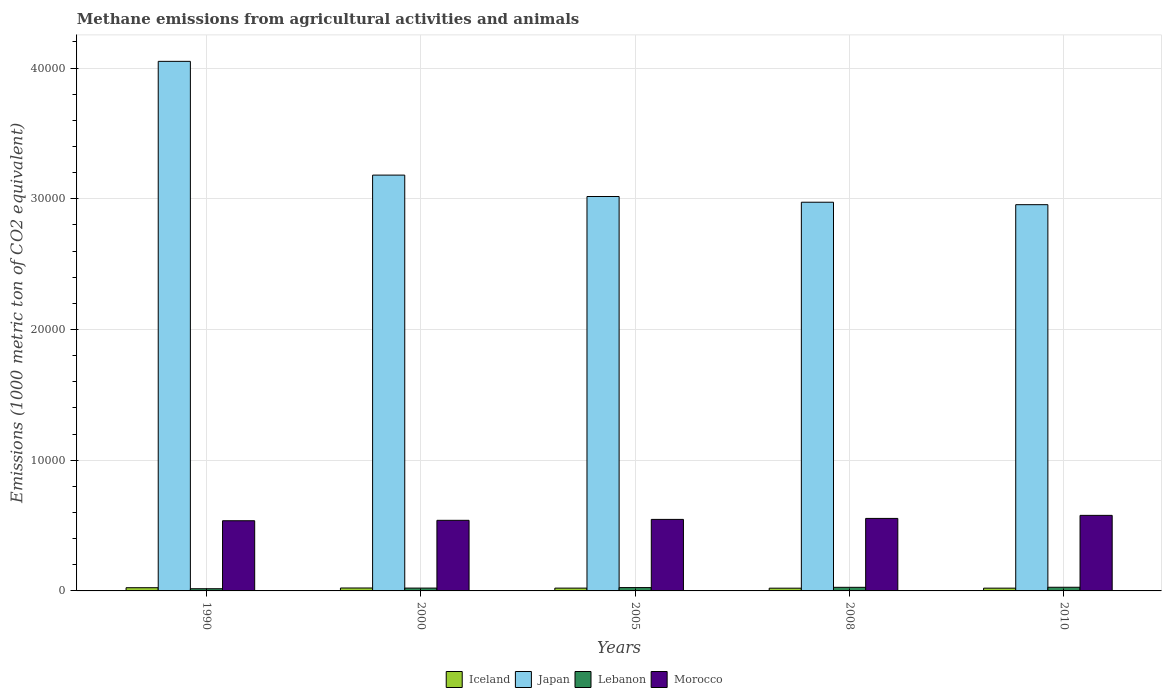How many different coloured bars are there?
Give a very brief answer. 4. How many bars are there on the 4th tick from the left?
Your answer should be compact. 4. What is the label of the 2nd group of bars from the left?
Your answer should be very brief. 2000. What is the amount of methane emitted in Japan in 2005?
Give a very brief answer. 3.02e+04. Across all years, what is the maximum amount of methane emitted in Iceland?
Your answer should be compact. 245.3. Across all years, what is the minimum amount of methane emitted in Iceland?
Make the answer very short. 209.2. In which year was the amount of methane emitted in Morocco minimum?
Ensure brevity in your answer.  1990. What is the total amount of methane emitted in Lebanon in the graph?
Your response must be concise. 1194.5. What is the difference between the amount of methane emitted in Japan in 2008 and the amount of methane emitted in Morocco in 2005?
Keep it short and to the point. 2.43e+04. What is the average amount of methane emitted in Morocco per year?
Provide a short and direct response. 5513.2. In the year 2000, what is the difference between the amount of methane emitted in Morocco and amount of methane emitted in Iceland?
Make the answer very short. 5176.6. What is the ratio of the amount of methane emitted in Iceland in 1990 to that in 2000?
Give a very brief answer. 1.1. Is the difference between the amount of methane emitted in Morocco in 2005 and 2008 greater than the difference between the amount of methane emitted in Iceland in 2005 and 2008?
Your response must be concise. No. What is the difference between the highest and the second highest amount of methane emitted in Japan?
Keep it short and to the point. 8700.7. What is the difference between the highest and the lowest amount of methane emitted in Iceland?
Provide a short and direct response. 36.1. What does the 1st bar from the left in 2005 represents?
Your response must be concise. Iceland. What does the 3rd bar from the right in 2008 represents?
Provide a succinct answer. Japan. Is it the case that in every year, the sum of the amount of methane emitted in Lebanon and amount of methane emitted in Iceland is greater than the amount of methane emitted in Morocco?
Your answer should be compact. No. Are all the bars in the graph horizontal?
Provide a succinct answer. No. How many years are there in the graph?
Provide a short and direct response. 5. Does the graph contain any zero values?
Make the answer very short. No. Does the graph contain grids?
Offer a very short reply. Yes. Where does the legend appear in the graph?
Make the answer very short. Bottom center. How are the legend labels stacked?
Ensure brevity in your answer.  Horizontal. What is the title of the graph?
Your response must be concise. Methane emissions from agricultural activities and animals. Does "Central Europe" appear as one of the legend labels in the graph?
Your response must be concise. No. What is the label or title of the Y-axis?
Give a very brief answer. Emissions (1000 metric ton of CO2 equivalent). What is the Emissions (1000 metric ton of CO2 equivalent) of Iceland in 1990?
Offer a terse response. 245.3. What is the Emissions (1000 metric ton of CO2 equivalent) of Japan in 1990?
Your answer should be very brief. 4.05e+04. What is the Emissions (1000 metric ton of CO2 equivalent) of Lebanon in 1990?
Offer a very short reply. 167.6. What is the Emissions (1000 metric ton of CO2 equivalent) of Morocco in 1990?
Offer a very short reply. 5368.8. What is the Emissions (1000 metric ton of CO2 equivalent) in Iceland in 2000?
Make the answer very short. 223.7. What is the Emissions (1000 metric ton of CO2 equivalent) in Japan in 2000?
Your answer should be compact. 3.18e+04. What is the Emissions (1000 metric ton of CO2 equivalent) of Lebanon in 2000?
Ensure brevity in your answer.  216.7. What is the Emissions (1000 metric ton of CO2 equivalent) of Morocco in 2000?
Offer a very short reply. 5400.3. What is the Emissions (1000 metric ton of CO2 equivalent) of Iceland in 2005?
Your answer should be compact. 214.9. What is the Emissions (1000 metric ton of CO2 equivalent) of Japan in 2005?
Offer a terse response. 3.02e+04. What is the Emissions (1000 metric ton of CO2 equivalent) of Lebanon in 2005?
Your answer should be very brief. 255.2. What is the Emissions (1000 metric ton of CO2 equivalent) of Morocco in 2005?
Give a very brief answer. 5471.4. What is the Emissions (1000 metric ton of CO2 equivalent) of Iceland in 2008?
Provide a short and direct response. 209.2. What is the Emissions (1000 metric ton of CO2 equivalent) in Japan in 2008?
Your response must be concise. 2.97e+04. What is the Emissions (1000 metric ton of CO2 equivalent) in Lebanon in 2008?
Ensure brevity in your answer.  275. What is the Emissions (1000 metric ton of CO2 equivalent) in Morocco in 2008?
Ensure brevity in your answer.  5546.4. What is the Emissions (1000 metric ton of CO2 equivalent) of Iceland in 2010?
Provide a succinct answer. 212.4. What is the Emissions (1000 metric ton of CO2 equivalent) of Japan in 2010?
Offer a very short reply. 2.95e+04. What is the Emissions (1000 metric ton of CO2 equivalent) in Lebanon in 2010?
Your response must be concise. 280. What is the Emissions (1000 metric ton of CO2 equivalent) in Morocco in 2010?
Your answer should be very brief. 5779.1. Across all years, what is the maximum Emissions (1000 metric ton of CO2 equivalent) in Iceland?
Your answer should be very brief. 245.3. Across all years, what is the maximum Emissions (1000 metric ton of CO2 equivalent) of Japan?
Provide a short and direct response. 4.05e+04. Across all years, what is the maximum Emissions (1000 metric ton of CO2 equivalent) in Lebanon?
Your response must be concise. 280. Across all years, what is the maximum Emissions (1000 metric ton of CO2 equivalent) in Morocco?
Give a very brief answer. 5779.1. Across all years, what is the minimum Emissions (1000 metric ton of CO2 equivalent) in Iceland?
Keep it short and to the point. 209.2. Across all years, what is the minimum Emissions (1000 metric ton of CO2 equivalent) in Japan?
Offer a terse response. 2.95e+04. Across all years, what is the minimum Emissions (1000 metric ton of CO2 equivalent) of Lebanon?
Provide a succinct answer. 167.6. Across all years, what is the minimum Emissions (1000 metric ton of CO2 equivalent) in Morocco?
Ensure brevity in your answer.  5368.8. What is the total Emissions (1000 metric ton of CO2 equivalent) in Iceland in the graph?
Offer a terse response. 1105.5. What is the total Emissions (1000 metric ton of CO2 equivalent) in Japan in the graph?
Offer a terse response. 1.62e+05. What is the total Emissions (1000 metric ton of CO2 equivalent) in Lebanon in the graph?
Give a very brief answer. 1194.5. What is the total Emissions (1000 metric ton of CO2 equivalent) of Morocco in the graph?
Your answer should be very brief. 2.76e+04. What is the difference between the Emissions (1000 metric ton of CO2 equivalent) in Iceland in 1990 and that in 2000?
Offer a terse response. 21.6. What is the difference between the Emissions (1000 metric ton of CO2 equivalent) in Japan in 1990 and that in 2000?
Your response must be concise. 8700.7. What is the difference between the Emissions (1000 metric ton of CO2 equivalent) of Lebanon in 1990 and that in 2000?
Offer a terse response. -49.1. What is the difference between the Emissions (1000 metric ton of CO2 equivalent) of Morocco in 1990 and that in 2000?
Your response must be concise. -31.5. What is the difference between the Emissions (1000 metric ton of CO2 equivalent) in Iceland in 1990 and that in 2005?
Offer a terse response. 30.4. What is the difference between the Emissions (1000 metric ton of CO2 equivalent) in Japan in 1990 and that in 2005?
Your answer should be compact. 1.03e+04. What is the difference between the Emissions (1000 metric ton of CO2 equivalent) of Lebanon in 1990 and that in 2005?
Your response must be concise. -87.6. What is the difference between the Emissions (1000 metric ton of CO2 equivalent) in Morocco in 1990 and that in 2005?
Your answer should be compact. -102.6. What is the difference between the Emissions (1000 metric ton of CO2 equivalent) in Iceland in 1990 and that in 2008?
Provide a short and direct response. 36.1. What is the difference between the Emissions (1000 metric ton of CO2 equivalent) in Japan in 1990 and that in 2008?
Offer a terse response. 1.08e+04. What is the difference between the Emissions (1000 metric ton of CO2 equivalent) of Lebanon in 1990 and that in 2008?
Ensure brevity in your answer.  -107.4. What is the difference between the Emissions (1000 metric ton of CO2 equivalent) in Morocco in 1990 and that in 2008?
Keep it short and to the point. -177.6. What is the difference between the Emissions (1000 metric ton of CO2 equivalent) in Iceland in 1990 and that in 2010?
Give a very brief answer. 32.9. What is the difference between the Emissions (1000 metric ton of CO2 equivalent) of Japan in 1990 and that in 2010?
Your answer should be very brief. 1.10e+04. What is the difference between the Emissions (1000 metric ton of CO2 equivalent) of Lebanon in 1990 and that in 2010?
Your response must be concise. -112.4. What is the difference between the Emissions (1000 metric ton of CO2 equivalent) of Morocco in 1990 and that in 2010?
Your response must be concise. -410.3. What is the difference between the Emissions (1000 metric ton of CO2 equivalent) in Iceland in 2000 and that in 2005?
Provide a succinct answer. 8.8. What is the difference between the Emissions (1000 metric ton of CO2 equivalent) of Japan in 2000 and that in 2005?
Your answer should be very brief. 1638. What is the difference between the Emissions (1000 metric ton of CO2 equivalent) in Lebanon in 2000 and that in 2005?
Provide a short and direct response. -38.5. What is the difference between the Emissions (1000 metric ton of CO2 equivalent) of Morocco in 2000 and that in 2005?
Keep it short and to the point. -71.1. What is the difference between the Emissions (1000 metric ton of CO2 equivalent) of Iceland in 2000 and that in 2008?
Make the answer very short. 14.5. What is the difference between the Emissions (1000 metric ton of CO2 equivalent) of Japan in 2000 and that in 2008?
Make the answer very short. 2075.3. What is the difference between the Emissions (1000 metric ton of CO2 equivalent) of Lebanon in 2000 and that in 2008?
Your response must be concise. -58.3. What is the difference between the Emissions (1000 metric ton of CO2 equivalent) in Morocco in 2000 and that in 2008?
Provide a succinct answer. -146.1. What is the difference between the Emissions (1000 metric ton of CO2 equivalent) in Iceland in 2000 and that in 2010?
Provide a succinct answer. 11.3. What is the difference between the Emissions (1000 metric ton of CO2 equivalent) of Japan in 2000 and that in 2010?
Provide a short and direct response. 2263.3. What is the difference between the Emissions (1000 metric ton of CO2 equivalent) of Lebanon in 2000 and that in 2010?
Provide a short and direct response. -63.3. What is the difference between the Emissions (1000 metric ton of CO2 equivalent) of Morocco in 2000 and that in 2010?
Provide a short and direct response. -378.8. What is the difference between the Emissions (1000 metric ton of CO2 equivalent) of Japan in 2005 and that in 2008?
Give a very brief answer. 437.3. What is the difference between the Emissions (1000 metric ton of CO2 equivalent) of Lebanon in 2005 and that in 2008?
Give a very brief answer. -19.8. What is the difference between the Emissions (1000 metric ton of CO2 equivalent) of Morocco in 2005 and that in 2008?
Make the answer very short. -75. What is the difference between the Emissions (1000 metric ton of CO2 equivalent) of Iceland in 2005 and that in 2010?
Offer a terse response. 2.5. What is the difference between the Emissions (1000 metric ton of CO2 equivalent) in Japan in 2005 and that in 2010?
Give a very brief answer. 625.3. What is the difference between the Emissions (1000 metric ton of CO2 equivalent) in Lebanon in 2005 and that in 2010?
Give a very brief answer. -24.8. What is the difference between the Emissions (1000 metric ton of CO2 equivalent) in Morocco in 2005 and that in 2010?
Your response must be concise. -307.7. What is the difference between the Emissions (1000 metric ton of CO2 equivalent) of Japan in 2008 and that in 2010?
Offer a very short reply. 188. What is the difference between the Emissions (1000 metric ton of CO2 equivalent) in Morocco in 2008 and that in 2010?
Give a very brief answer. -232.7. What is the difference between the Emissions (1000 metric ton of CO2 equivalent) in Iceland in 1990 and the Emissions (1000 metric ton of CO2 equivalent) in Japan in 2000?
Give a very brief answer. -3.16e+04. What is the difference between the Emissions (1000 metric ton of CO2 equivalent) in Iceland in 1990 and the Emissions (1000 metric ton of CO2 equivalent) in Lebanon in 2000?
Give a very brief answer. 28.6. What is the difference between the Emissions (1000 metric ton of CO2 equivalent) in Iceland in 1990 and the Emissions (1000 metric ton of CO2 equivalent) in Morocco in 2000?
Give a very brief answer. -5155. What is the difference between the Emissions (1000 metric ton of CO2 equivalent) of Japan in 1990 and the Emissions (1000 metric ton of CO2 equivalent) of Lebanon in 2000?
Make the answer very short. 4.03e+04. What is the difference between the Emissions (1000 metric ton of CO2 equivalent) of Japan in 1990 and the Emissions (1000 metric ton of CO2 equivalent) of Morocco in 2000?
Keep it short and to the point. 3.51e+04. What is the difference between the Emissions (1000 metric ton of CO2 equivalent) in Lebanon in 1990 and the Emissions (1000 metric ton of CO2 equivalent) in Morocco in 2000?
Offer a very short reply. -5232.7. What is the difference between the Emissions (1000 metric ton of CO2 equivalent) of Iceland in 1990 and the Emissions (1000 metric ton of CO2 equivalent) of Japan in 2005?
Your answer should be compact. -2.99e+04. What is the difference between the Emissions (1000 metric ton of CO2 equivalent) of Iceland in 1990 and the Emissions (1000 metric ton of CO2 equivalent) of Morocco in 2005?
Your answer should be very brief. -5226.1. What is the difference between the Emissions (1000 metric ton of CO2 equivalent) of Japan in 1990 and the Emissions (1000 metric ton of CO2 equivalent) of Lebanon in 2005?
Your response must be concise. 4.03e+04. What is the difference between the Emissions (1000 metric ton of CO2 equivalent) in Japan in 1990 and the Emissions (1000 metric ton of CO2 equivalent) in Morocco in 2005?
Offer a terse response. 3.50e+04. What is the difference between the Emissions (1000 metric ton of CO2 equivalent) of Lebanon in 1990 and the Emissions (1000 metric ton of CO2 equivalent) of Morocco in 2005?
Your answer should be compact. -5303.8. What is the difference between the Emissions (1000 metric ton of CO2 equivalent) of Iceland in 1990 and the Emissions (1000 metric ton of CO2 equivalent) of Japan in 2008?
Keep it short and to the point. -2.95e+04. What is the difference between the Emissions (1000 metric ton of CO2 equivalent) in Iceland in 1990 and the Emissions (1000 metric ton of CO2 equivalent) in Lebanon in 2008?
Ensure brevity in your answer.  -29.7. What is the difference between the Emissions (1000 metric ton of CO2 equivalent) of Iceland in 1990 and the Emissions (1000 metric ton of CO2 equivalent) of Morocco in 2008?
Provide a succinct answer. -5301.1. What is the difference between the Emissions (1000 metric ton of CO2 equivalent) in Japan in 1990 and the Emissions (1000 metric ton of CO2 equivalent) in Lebanon in 2008?
Your answer should be compact. 4.02e+04. What is the difference between the Emissions (1000 metric ton of CO2 equivalent) in Japan in 1990 and the Emissions (1000 metric ton of CO2 equivalent) in Morocco in 2008?
Ensure brevity in your answer.  3.50e+04. What is the difference between the Emissions (1000 metric ton of CO2 equivalent) of Lebanon in 1990 and the Emissions (1000 metric ton of CO2 equivalent) of Morocco in 2008?
Offer a terse response. -5378.8. What is the difference between the Emissions (1000 metric ton of CO2 equivalent) of Iceland in 1990 and the Emissions (1000 metric ton of CO2 equivalent) of Japan in 2010?
Offer a terse response. -2.93e+04. What is the difference between the Emissions (1000 metric ton of CO2 equivalent) of Iceland in 1990 and the Emissions (1000 metric ton of CO2 equivalent) of Lebanon in 2010?
Your answer should be compact. -34.7. What is the difference between the Emissions (1000 metric ton of CO2 equivalent) in Iceland in 1990 and the Emissions (1000 metric ton of CO2 equivalent) in Morocco in 2010?
Keep it short and to the point. -5533.8. What is the difference between the Emissions (1000 metric ton of CO2 equivalent) of Japan in 1990 and the Emissions (1000 metric ton of CO2 equivalent) of Lebanon in 2010?
Your response must be concise. 4.02e+04. What is the difference between the Emissions (1000 metric ton of CO2 equivalent) in Japan in 1990 and the Emissions (1000 metric ton of CO2 equivalent) in Morocco in 2010?
Make the answer very short. 3.47e+04. What is the difference between the Emissions (1000 metric ton of CO2 equivalent) in Lebanon in 1990 and the Emissions (1000 metric ton of CO2 equivalent) in Morocco in 2010?
Make the answer very short. -5611.5. What is the difference between the Emissions (1000 metric ton of CO2 equivalent) in Iceland in 2000 and the Emissions (1000 metric ton of CO2 equivalent) in Japan in 2005?
Offer a very short reply. -2.99e+04. What is the difference between the Emissions (1000 metric ton of CO2 equivalent) in Iceland in 2000 and the Emissions (1000 metric ton of CO2 equivalent) in Lebanon in 2005?
Give a very brief answer. -31.5. What is the difference between the Emissions (1000 metric ton of CO2 equivalent) in Iceland in 2000 and the Emissions (1000 metric ton of CO2 equivalent) in Morocco in 2005?
Offer a terse response. -5247.7. What is the difference between the Emissions (1000 metric ton of CO2 equivalent) in Japan in 2000 and the Emissions (1000 metric ton of CO2 equivalent) in Lebanon in 2005?
Offer a terse response. 3.16e+04. What is the difference between the Emissions (1000 metric ton of CO2 equivalent) in Japan in 2000 and the Emissions (1000 metric ton of CO2 equivalent) in Morocco in 2005?
Keep it short and to the point. 2.63e+04. What is the difference between the Emissions (1000 metric ton of CO2 equivalent) of Lebanon in 2000 and the Emissions (1000 metric ton of CO2 equivalent) of Morocco in 2005?
Ensure brevity in your answer.  -5254.7. What is the difference between the Emissions (1000 metric ton of CO2 equivalent) of Iceland in 2000 and the Emissions (1000 metric ton of CO2 equivalent) of Japan in 2008?
Offer a terse response. -2.95e+04. What is the difference between the Emissions (1000 metric ton of CO2 equivalent) of Iceland in 2000 and the Emissions (1000 metric ton of CO2 equivalent) of Lebanon in 2008?
Ensure brevity in your answer.  -51.3. What is the difference between the Emissions (1000 metric ton of CO2 equivalent) in Iceland in 2000 and the Emissions (1000 metric ton of CO2 equivalent) in Morocco in 2008?
Provide a succinct answer. -5322.7. What is the difference between the Emissions (1000 metric ton of CO2 equivalent) in Japan in 2000 and the Emissions (1000 metric ton of CO2 equivalent) in Lebanon in 2008?
Keep it short and to the point. 3.15e+04. What is the difference between the Emissions (1000 metric ton of CO2 equivalent) in Japan in 2000 and the Emissions (1000 metric ton of CO2 equivalent) in Morocco in 2008?
Provide a succinct answer. 2.63e+04. What is the difference between the Emissions (1000 metric ton of CO2 equivalent) in Lebanon in 2000 and the Emissions (1000 metric ton of CO2 equivalent) in Morocco in 2008?
Keep it short and to the point. -5329.7. What is the difference between the Emissions (1000 metric ton of CO2 equivalent) of Iceland in 2000 and the Emissions (1000 metric ton of CO2 equivalent) of Japan in 2010?
Offer a very short reply. -2.93e+04. What is the difference between the Emissions (1000 metric ton of CO2 equivalent) of Iceland in 2000 and the Emissions (1000 metric ton of CO2 equivalent) of Lebanon in 2010?
Keep it short and to the point. -56.3. What is the difference between the Emissions (1000 metric ton of CO2 equivalent) in Iceland in 2000 and the Emissions (1000 metric ton of CO2 equivalent) in Morocco in 2010?
Make the answer very short. -5555.4. What is the difference between the Emissions (1000 metric ton of CO2 equivalent) of Japan in 2000 and the Emissions (1000 metric ton of CO2 equivalent) of Lebanon in 2010?
Ensure brevity in your answer.  3.15e+04. What is the difference between the Emissions (1000 metric ton of CO2 equivalent) of Japan in 2000 and the Emissions (1000 metric ton of CO2 equivalent) of Morocco in 2010?
Your response must be concise. 2.60e+04. What is the difference between the Emissions (1000 metric ton of CO2 equivalent) of Lebanon in 2000 and the Emissions (1000 metric ton of CO2 equivalent) of Morocco in 2010?
Give a very brief answer. -5562.4. What is the difference between the Emissions (1000 metric ton of CO2 equivalent) of Iceland in 2005 and the Emissions (1000 metric ton of CO2 equivalent) of Japan in 2008?
Your response must be concise. -2.95e+04. What is the difference between the Emissions (1000 metric ton of CO2 equivalent) of Iceland in 2005 and the Emissions (1000 metric ton of CO2 equivalent) of Lebanon in 2008?
Your answer should be compact. -60.1. What is the difference between the Emissions (1000 metric ton of CO2 equivalent) of Iceland in 2005 and the Emissions (1000 metric ton of CO2 equivalent) of Morocco in 2008?
Keep it short and to the point. -5331.5. What is the difference between the Emissions (1000 metric ton of CO2 equivalent) in Japan in 2005 and the Emissions (1000 metric ton of CO2 equivalent) in Lebanon in 2008?
Offer a very short reply. 2.99e+04. What is the difference between the Emissions (1000 metric ton of CO2 equivalent) of Japan in 2005 and the Emissions (1000 metric ton of CO2 equivalent) of Morocco in 2008?
Provide a short and direct response. 2.46e+04. What is the difference between the Emissions (1000 metric ton of CO2 equivalent) in Lebanon in 2005 and the Emissions (1000 metric ton of CO2 equivalent) in Morocco in 2008?
Keep it short and to the point. -5291.2. What is the difference between the Emissions (1000 metric ton of CO2 equivalent) in Iceland in 2005 and the Emissions (1000 metric ton of CO2 equivalent) in Japan in 2010?
Your answer should be compact. -2.93e+04. What is the difference between the Emissions (1000 metric ton of CO2 equivalent) in Iceland in 2005 and the Emissions (1000 metric ton of CO2 equivalent) in Lebanon in 2010?
Your answer should be compact. -65.1. What is the difference between the Emissions (1000 metric ton of CO2 equivalent) in Iceland in 2005 and the Emissions (1000 metric ton of CO2 equivalent) in Morocco in 2010?
Your answer should be very brief. -5564.2. What is the difference between the Emissions (1000 metric ton of CO2 equivalent) in Japan in 2005 and the Emissions (1000 metric ton of CO2 equivalent) in Lebanon in 2010?
Your answer should be compact. 2.99e+04. What is the difference between the Emissions (1000 metric ton of CO2 equivalent) in Japan in 2005 and the Emissions (1000 metric ton of CO2 equivalent) in Morocco in 2010?
Your response must be concise. 2.44e+04. What is the difference between the Emissions (1000 metric ton of CO2 equivalent) of Lebanon in 2005 and the Emissions (1000 metric ton of CO2 equivalent) of Morocco in 2010?
Your response must be concise. -5523.9. What is the difference between the Emissions (1000 metric ton of CO2 equivalent) in Iceland in 2008 and the Emissions (1000 metric ton of CO2 equivalent) in Japan in 2010?
Your answer should be very brief. -2.93e+04. What is the difference between the Emissions (1000 metric ton of CO2 equivalent) of Iceland in 2008 and the Emissions (1000 metric ton of CO2 equivalent) of Lebanon in 2010?
Keep it short and to the point. -70.8. What is the difference between the Emissions (1000 metric ton of CO2 equivalent) in Iceland in 2008 and the Emissions (1000 metric ton of CO2 equivalent) in Morocco in 2010?
Your response must be concise. -5569.9. What is the difference between the Emissions (1000 metric ton of CO2 equivalent) of Japan in 2008 and the Emissions (1000 metric ton of CO2 equivalent) of Lebanon in 2010?
Offer a terse response. 2.95e+04. What is the difference between the Emissions (1000 metric ton of CO2 equivalent) in Japan in 2008 and the Emissions (1000 metric ton of CO2 equivalent) in Morocco in 2010?
Provide a succinct answer. 2.40e+04. What is the difference between the Emissions (1000 metric ton of CO2 equivalent) in Lebanon in 2008 and the Emissions (1000 metric ton of CO2 equivalent) in Morocco in 2010?
Provide a succinct answer. -5504.1. What is the average Emissions (1000 metric ton of CO2 equivalent) of Iceland per year?
Offer a very short reply. 221.1. What is the average Emissions (1000 metric ton of CO2 equivalent) in Japan per year?
Provide a succinct answer. 3.24e+04. What is the average Emissions (1000 metric ton of CO2 equivalent) of Lebanon per year?
Your response must be concise. 238.9. What is the average Emissions (1000 metric ton of CO2 equivalent) in Morocco per year?
Offer a terse response. 5513.2. In the year 1990, what is the difference between the Emissions (1000 metric ton of CO2 equivalent) in Iceland and Emissions (1000 metric ton of CO2 equivalent) in Japan?
Your answer should be very brief. -4.03e+04. In the year 1990, what is the difference between the Emissions (1000 metric ton of CO2 equivalent) in Iceland and Emissions (1000 metric ton of CO2 equivalent) in Lebanon?
Your answer should be very brief. 77.7. In the year 1990, what is the difference between the Emissions (1000 metric ton of CO2 equivalent) in Iceland and Emissions (1000 metric ton of CO2 equivalent) in Morocco?
Your response must be concise. -5123.5. In the year 1990, what is the difference between the Emissions (1000 metric ton of CO2 equivalent) of Japan and Emissions (1000 metric ton of CO2 equivalent) of Lebanon?
Keep it short and to the point. 4.03e+04. In the year 1990, what is the difference between the Emissions (1000 metric ton of CO2 equivalent) of Japan and Emissions (1000 metric ton of CO2 equivalent) of Morocco?
Provide a succinct answer. 3.51e+04. In the year 1990, what is the difference between the Emissions (1000 metric ton of CO2 equivalent) of Lebanon and Emissions (1000 metric ton of CO2 equivalent) of Morocco?
Provide a succinct answer. -5201.2. In the year 2000, what is the difference between the Emissions (1000 metric ton of CO2 equivalent) in Iceland and Emissions (1000 metric ton of CO2 equivalent) in Japan?
Provide a short and direct response. -3.16e+04. In the year 2000, what is the difference between the Emissions (1000 metric ton of CO2 equivalent) in Iceland and Emissions (1000 metric ton of CO2 equivalent) in Lebanon?
Provide a short and direct response. 7. In the year 2000, what is the difference between the Emissions (1000 metric ton of CO2 equivalent) of Iceland and Emissions (1000 metric ton of CO2 equivalent) of Morocco?
Offer a very short reply. -5176.6. In the year 2000, what is the difference between the Emissions (1000 metric ton of CO2 equivalent) in Japan and Emissions (1000 metric ton of CO2 equivalent) in Lebanon?
Your response must be concise. 3.16e+04. In the year 2000, what is the difference between the Emissions (1000 metric ton of CO2 equivalent) of Japan and Emissions (1000 metric ton of CO2 equivalent) of Morocco?
Give a very brief answer. 2.64e+04. In the year 2000, what is the difference between the Emissions (1000 metric ton of CO2 equivalent) in Lebanon and Emissions (1000 metric ton of CO2 equivalent) in Morocco?
Provide a succinct answer. -5183.6. In the year 2005, what is the difference between the Emissions (1000 metric ton of CO2 equivalent) in Iceland and Emissions (1000 metric ton of CO2 equivalent) in Japan?
Offer a terse response. -3.00e+04. In the year 2005, what is the difference between the Emissions (1000 metric ton of CO2 equivalent) of Iceland and Emissions (1000 metric ton of CO2 equivalent) of Lebanon?
Keep it short and to the point. -40.3. In the year 2005, what is the difference between the Emissions (1000 metric ton of CO2 equivalent) in Iceland and Emissions (1000 metric ton of CO2 equivalent) in Morocco?
Provide a short and direct response. -5256.5. In the year 2005, what is the difference between the Emissions (1000 metric ton of CO2 equivalent) in Japan and Emissions (1000 metric ton of CO2 equivalent) in Lebanon?
Your answer should be very brief. 2.99e+04. In the year 2005, what is the difference between the Emissions (1000 metric ton of CO2 equivalent) of Japan and Emissions (1000 metric ton of CO2 equivalent) of Morocco?
Your answer should be very brief. 2.47e+04. In the year 2005, what is the difference between the Emissions (1000 metric ton of CO2 equivalent) of Lebanon and Emissions (1000 metric ton of CO2 equivalent) of Morocco?
Offer a terse response. -5216.2. In the year 2008, what is the difference between the Emissions (1000 metric ton of CO2 equivalent) in Iceland and Emissions (1000 metric ton of CO2 equivalent) in Japan?
Ensure brevity in your answer.  -2.95e+04. In the year 2008, what is the difference between the Emissions (1000 metric ton of CO2 equivalent) in Iceland and Emissions (1000 metric ton of CO2 equivalent) in Lebanon?
Offer a very short reply. -65.8. In the year 2008, what is the difference between the Emissions (1000 metric ton of CO2 equivalent) of Iceland and Emissions (1000 metric ton of CO2 equivalent) of Morocco?
Provide a short and direct response. -5337.2. In the year 2008, what is the difference between the Emissions (1000 metric ton of CO2 equivalent) in Japan and Emissions (1000 metric ton of CO2 equivalent) in Lebanon?
Ensure brevity in your answer.  2.95e+04. In the year 2008, what is the difference between the Emissions (1000 metric ton of CO2 equivalent) of Japan and Emissions (1000 metric ton of CO2 equivalent) of Morocco?
Keep it short and to the point. 2.42e+04. In the year 2008, what is the difference between the Emissions (1000 metric ton of CO2 equivalent) of Lebanon and Emissions (1000 metric ton of CO2 equivalent) of Morocco?
Make the answer very short. -5271.4. In the year 2010, what is the difference between the Emissions (1000 metric ton of CO2 equivalent) in Iceland and Emissions (1000 metric ton of CO2 equivalent) in Japan?
Ensure brevity in your answer.  -2.93e+04. In the year 2010, what is the difference between the Emissions (1000 metric ton of CO2 equivalent) of Iceland and Emissions (1000 metric ton of CO2 equivalent) of Lebanon?
Make the answer very short. -67.6. In the year 2010, what is the difference between the Emissions (1000 metric ton of CO2 equivalent) of Iceland and Emissions (1000 metric ton of CO2 equivalent) of Morocco?
Provide a short and direct response. -5566.7. In the year 2010, what is the difference between the Emissions (1000 metric ton of CO2 equivalent) of Japan and Emissions (1000 metric ton of CO2 equivalent) of Lebanon?
Your answer should be very brief. 2.93e+04. In the year 2010, what is the difference between the Emissions (1000 metric ton of CO2 equivalent) in Japan and Emissions (1000 metric ton of CO2 equivalent) in Morocco?
Your answer should be very brief. 2.38e+04. In the year 2010, what is the difference between the Emissions (1000 metric ton of CO2 equivalent) in Lebanon and Emissions (1000 metric ton of CO2 equivalent) in Morocco?
Provide a succinct answer. -5499.1. What is the ratio of the Emissions (1000 metric ton of CO2 equivalent) in Iceland in 1990 to that in 2000?
Your answer should be compact. 1.1. What is the ratio of the Emissions (1000 metric ton of CO2 equivalent) in Japan in 1990 to that in 2000?
Offer a terse response. 1.27. What is the ratio of the Emissions (1000 metric ton of CO2 equivalent) in Lebanon in 1990 to that in 2000?
Make the answer very short. 0.77. What is the ratio of the Emissions (1000 metric ton of CO2 equivalent) of Iceland in 1990 to that in 2005?
Keep it short and to the point. 1.14. What is the ratio of the Emissions (1000 metric ton of CO2 equivalent) of Japan in 1990 to that in 2005?
Offer a very short reply. 1.34. What is the ratio of the Emissions (1000 metric ton of CO2 equivalent) of Lebanon in 1990 to that in 2005?
Keep it short and to the point. 0.66. What is the ratio of the Emissions (1000 metric ton of CO2 equivalent) in Morocco in 1990 to that in 2005?
Offer a very short reply. 0.98. What is the ratio of the Emissions (1000 metric ton of CO2 equivalent) of Iceland in 1990 to that in 2008?
Offer a very short reply. 1.17. What is the ratio of the Emissions (1000 metric ton of CO2 equivalent) of Japan in 1990 to that in 2008?
Keep it short and to the point. 1.36. What is the ratio of the Emissions (1000 metric ton of CO2 equivalent) of Lebanon in 1990 to that in 2008?
Provide a short and direct response. 0.61. What is the ratio of the Emissions (1000 metric ton of CO2 equivalent) of Morocco in 1990 to that in 2008?
Ensure brevity in your answer.  0.97. What is the ratio of the Emissions (1000 metric ton of CO2 equivalent) in Iceland in 1990 to that in 2010?
Ensure brevity in your answer.  1.15. What is the ratio of the Emissions (1000 metric ton of CO2 equivalent) in Japan in 1990 to that in 2010?
Make the answer very short. 1.37. What is the ratio of the Emissions (1000 metric ton of CO2 equivalent) in Lebanon in 1990 to that in 2010?
Make the answer very short. 0.6. What is the ratio of the Emissions (1000 metric ton of CO2 equivalent) in Morocco in 1990 to that in 2010?
Ensure brevity in your answer.  0.93. What is the ratio of the Emissions (1000 metric ton of CO2 equivalent) in Iceland in 2000 to that in 2005?
Ensure brevity in your answer.  1.04. What is the ratio of the Emissions (1000 metric ton of CO2 equivalent) of Japan in 2000 to that in 2005?
Your answer should be very brief. 1.05. What is the ratio of the Emissions (1000 metric ton of CO2 equivalent) of Lebanon in 2000 to that in 2005?
Provide a short and direct response. 0.85. What is the ratio of the Emissions (1000 metric ton of CO2 equivalent) in Morocco in 2000 to that in 2005?
Give a very brief answer. 0.99. What is the ratio of the Emissions (1000 metric ton of CO2 equivalent) in Iceland in 2000 to that in 2008?
Ensure brevity in your answer.  1.07. What is the ratio of the Emissions (1000 metric ton of CO2 equivalent) of Japan in 2000 to that in 2008?
Your response must be concise. 1.07. What is the ratio of the Emissions (1000 metric ton of CO2 equivalent) of Lebanon in 2000 to that in 2008?
Your response must be concise. 0.79. What is the ratio of the Emissions (1000 metric ton of CO2 equivalent) of Morocco in 2000 to that in 2008?
Offer a terse response. 0.97. What is the ratio of the Emissions (1000 metric ton of CO2 equivalent) in Iceland in 2000 to that in 2010?
Give a very brief answer. 1.05. What is the ratio of the Emissions (1000 metric ton of CO2 equivalent) in Japan in 2000 to that in 2010?
Provide a succinct answer. 1.08. What is the ratio of the Emissions (1000 metric ton of CO2 equivalent) of Lebanon in 2000 to that in 2010?
Offer a terse response. 0.77. What is the ratio of the Emissions (1000 metric ton of CO2 equivalent) in Morocco in 2000 to that in 2010?
Make the answer very short. 0.93. What is the ratio of the Emissions (1000 metric ton of CO2 equivalent) in Iceland in 2005 to that in 2008?
Provide a succinct answer. 1.03. What is the ratio of the Emissions (1000 metric ton of CO2 equivalent) in Japan in 2005 to that in 2008?
Provide a succinct answer. 1.01. What is the ratio of the Emissions (1000 metric ton of CO2 equivalent) of Lebanon in 2005 to that in 2008?
Make the answer very short. 0.93. What is the ratio of the Emissions (1000 metric ton of CO2 equivalent) in Morocco in 2005 to that in 2008?
Offer a terse response. 0.99. What is the ratio of the Emissions (1000 metric ton of CO2 equivalent) in Iceland in 2005 to that in 2010?
Your answer should be compact. 1.01. What is the ratio of the Emissions (1000 metric ton of CO2 equivalent) in Japan in 2005 to that in 2010?
Give a very brief answer. 1.02. What is the ratio of the Emissions (1000 metric ton of CO2 equivalent) in Lebanon in 2005 to that in 2010?
Offer a very short reply. 0.91. What is the ratio of the Emissions (1000 metric ton of CO2 equivalent) in Morocco in 2005 to that in 2010?
Keep it short and to the point. 0.95. What is the ratio of the Emissions (1000 metric ton of CO2 equivalent) of Iceland in 2008 to that in 2010?
Your response must be concise. 0.98. What is the ratio of the Emissions (1000 metric ton of CO2 equivalent) in Japan in 2008 to that in 2010?
Provide a short and direct response. 1.01. What is the ratio of the Emissions (1000 metric ton of CO2 equivalent) of Lebanon in 2008 to that in 2010?
Offer a very short reply. 0.98. What is the ratio of the Emissions (1000 metric ton of CO2 equivalent) in Morocco in 2008 to that in 2010?
Offer a terse response. 0.96. What is the difference between the highest and the second highest Emissions (1000 metric ton of CO2 equivalent) in Iceland?
Provide a succinct answer. 21.6. What is the difference between the highest and the second highest Emissions (1000 metric ton of CO2 equivalent) in Japan?
Provide a short and direct response. 8700.7. What is the difference between the highest and the second highest Emissions (1000 metric ton of CO2 equivalent) of Lebanon?
Offer a very short reply. 5. What is the difference between the highest and the second highest Emissions (1000 metric ton of CO2 equivalent) of Morocco?
Your answer should be very brief. 232.7. What is the difference between the highest and the lowest Emissions (1000 metric ton of CO2 equivalent) of Iceland?
Offer a very short reply. 36.1. What is the difference between the highest and the lowest Emissions (1000 metric ton of CO2 equivalent) in Japan?
Your response must be concise. 1.10e+04. What is the difference between the highest and the lowest Emissions (1000 metric ton of CO2 equivalent) in Lebanon?
Provide a short and direct response. 112.4. What is the difference between the highest and the lowest Emissions (1000 metric ton of CO2 equivalent) in Morocco?
Provide a succinct answer. 410.3. 